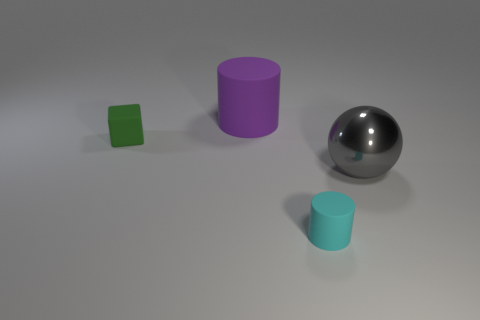What might these objects represent, and can you correlate them to real-world objects? The objects resemble simple geometric shapes that might be used as teaching aids in a classroom to help students learn about different forms and volumes. The large purple cylinder could represent a container like a cup; the tiny green block might be akin to a dice or a child's toy block; the semi-matte cylinder could be seen as a cup holder or a small storage container, and the reflective sphere can be reminiscent of a decorative bauble or even a large metallic ball bearing. 